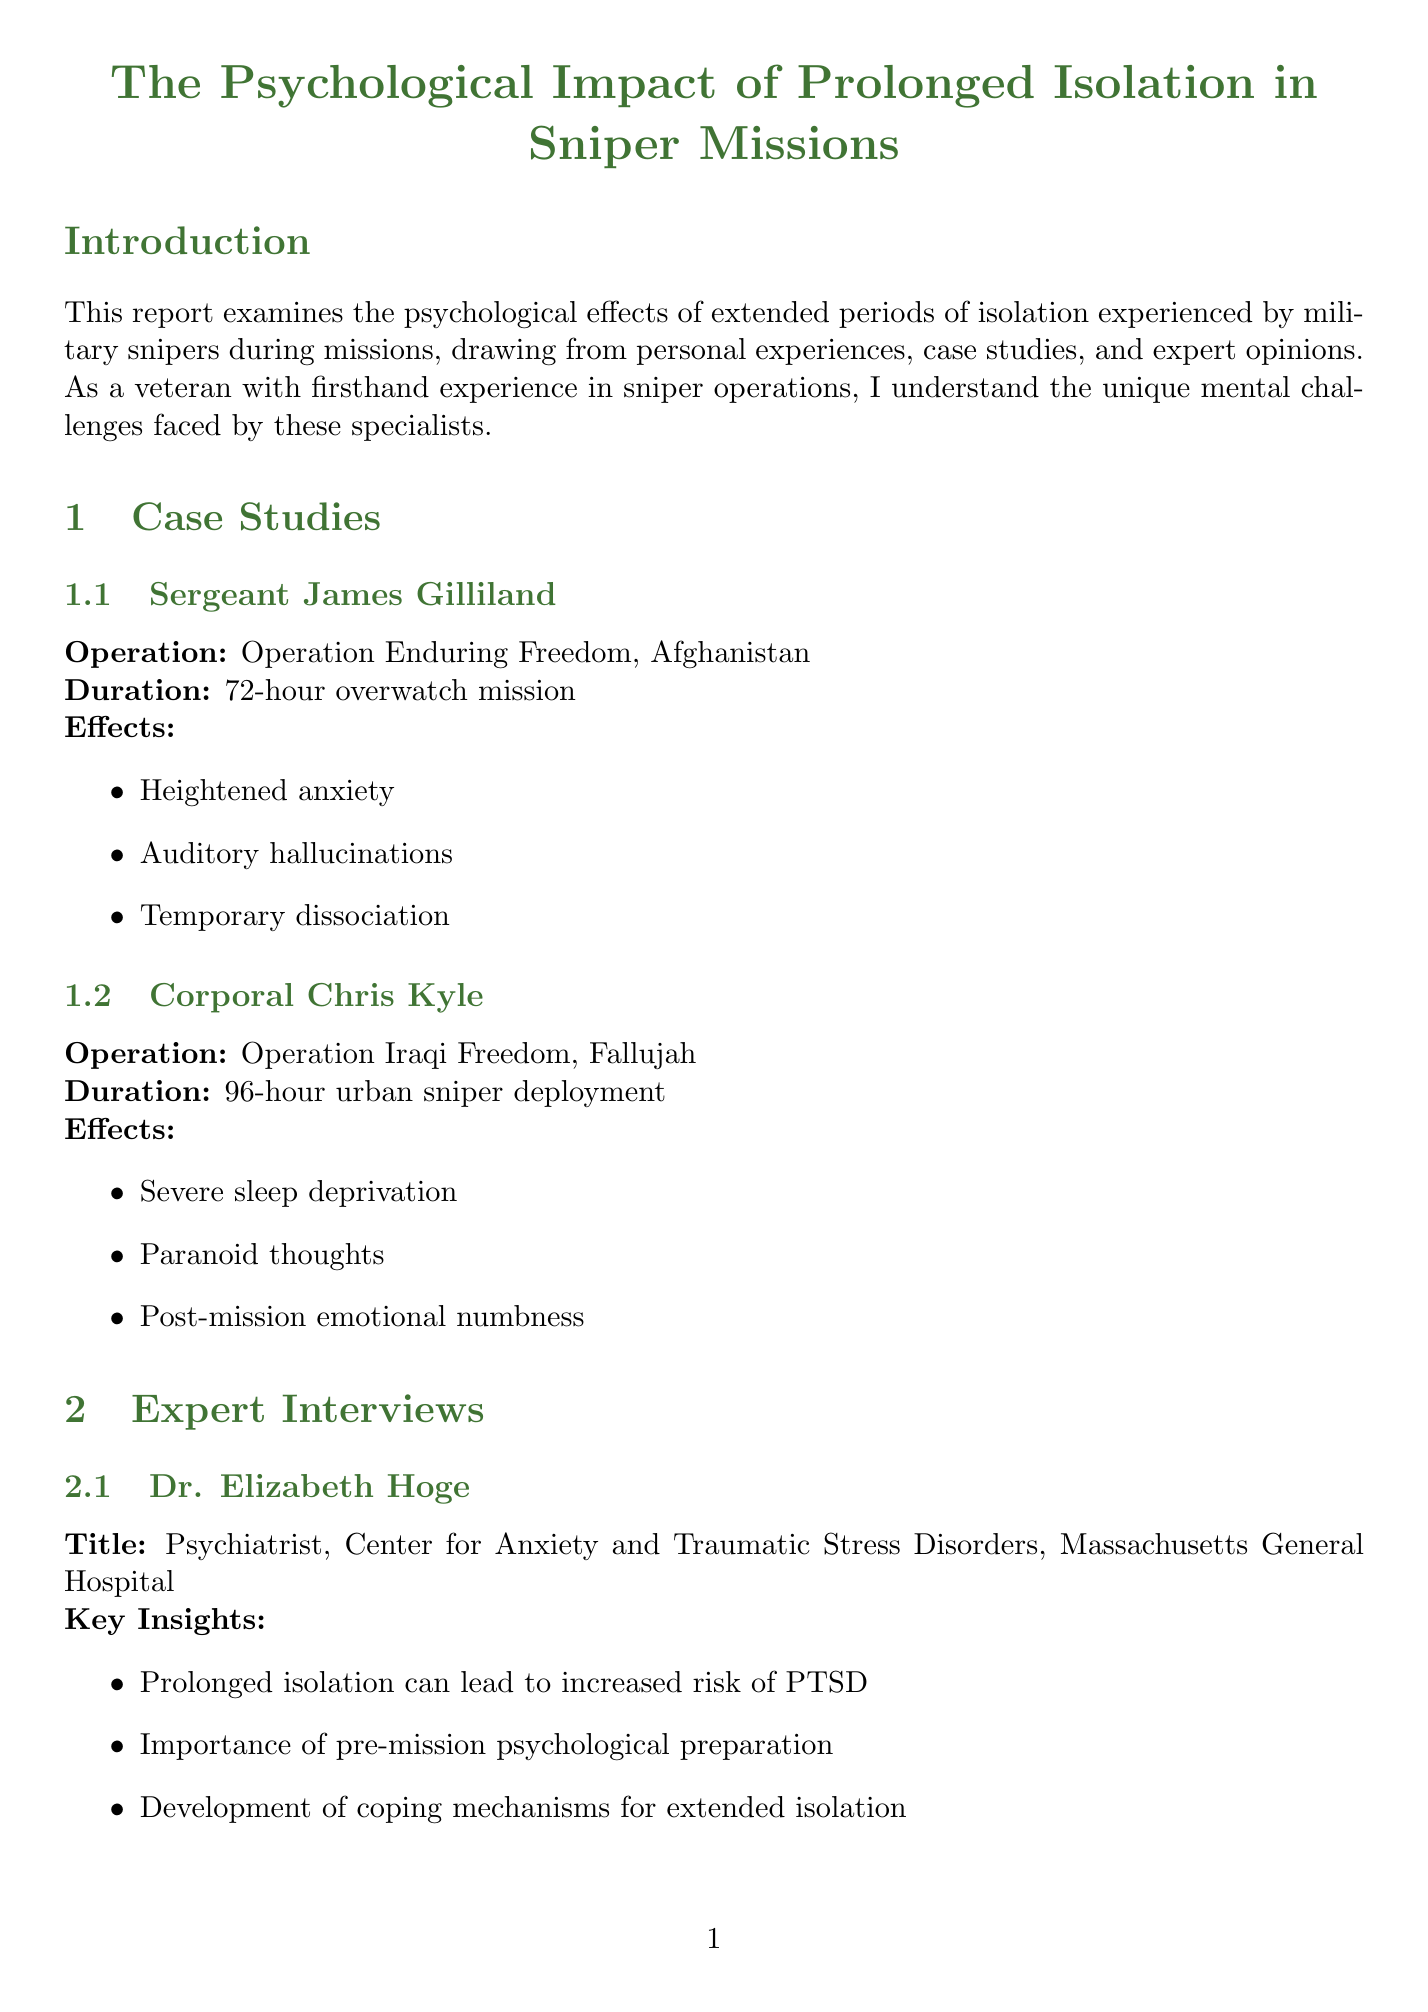What is the title of the report? The title of the report is featured prominently at the beginning of the document.
Answer: The Psychological Impact of Prolonged Isolation in Sniper Missions Who conducted the study on psychological effects? The introduction states that the report draws from personal experiences, case studies, and expert opinions.
Answer: A detailed study What is the duration of Sergeant James Gilliland's mission? The specific duration of Sergeant James Gilliland's mission is provided under his case study.
Answer: 72-hour overwatch mission What are the key insights provided by Dr. Elizabeth Hoge? This information is listed under her expert interview section.
Answer: Prolonged isolation can lead to increased risk of PTSD What is one coping strategy mentioned in the report? The coping strategies are outlined in a dedicated section of the report.
Answer: Mindfulness and meditation techniques What long-term implication is associated with prolonged isolation? The long-term implications are listed, providing specific adverse outcomes.
Answer: Increased risk of PTSD and other anxiety disorders What is one recommendation made in the report? The recommendations are outlined clearly towards the end of the document.
Answer: Enhanced pre-deployment psychological screening What psychological effect is categorized under "Emotional"? The document lists specific subcategories of psychological effects.
Answer: Increased irritability What operation is Corporal Chris Kyle associated with? The operation is mentioned alongside his case study.
Answer: Operation Iraqi Freedom, Fallujah 